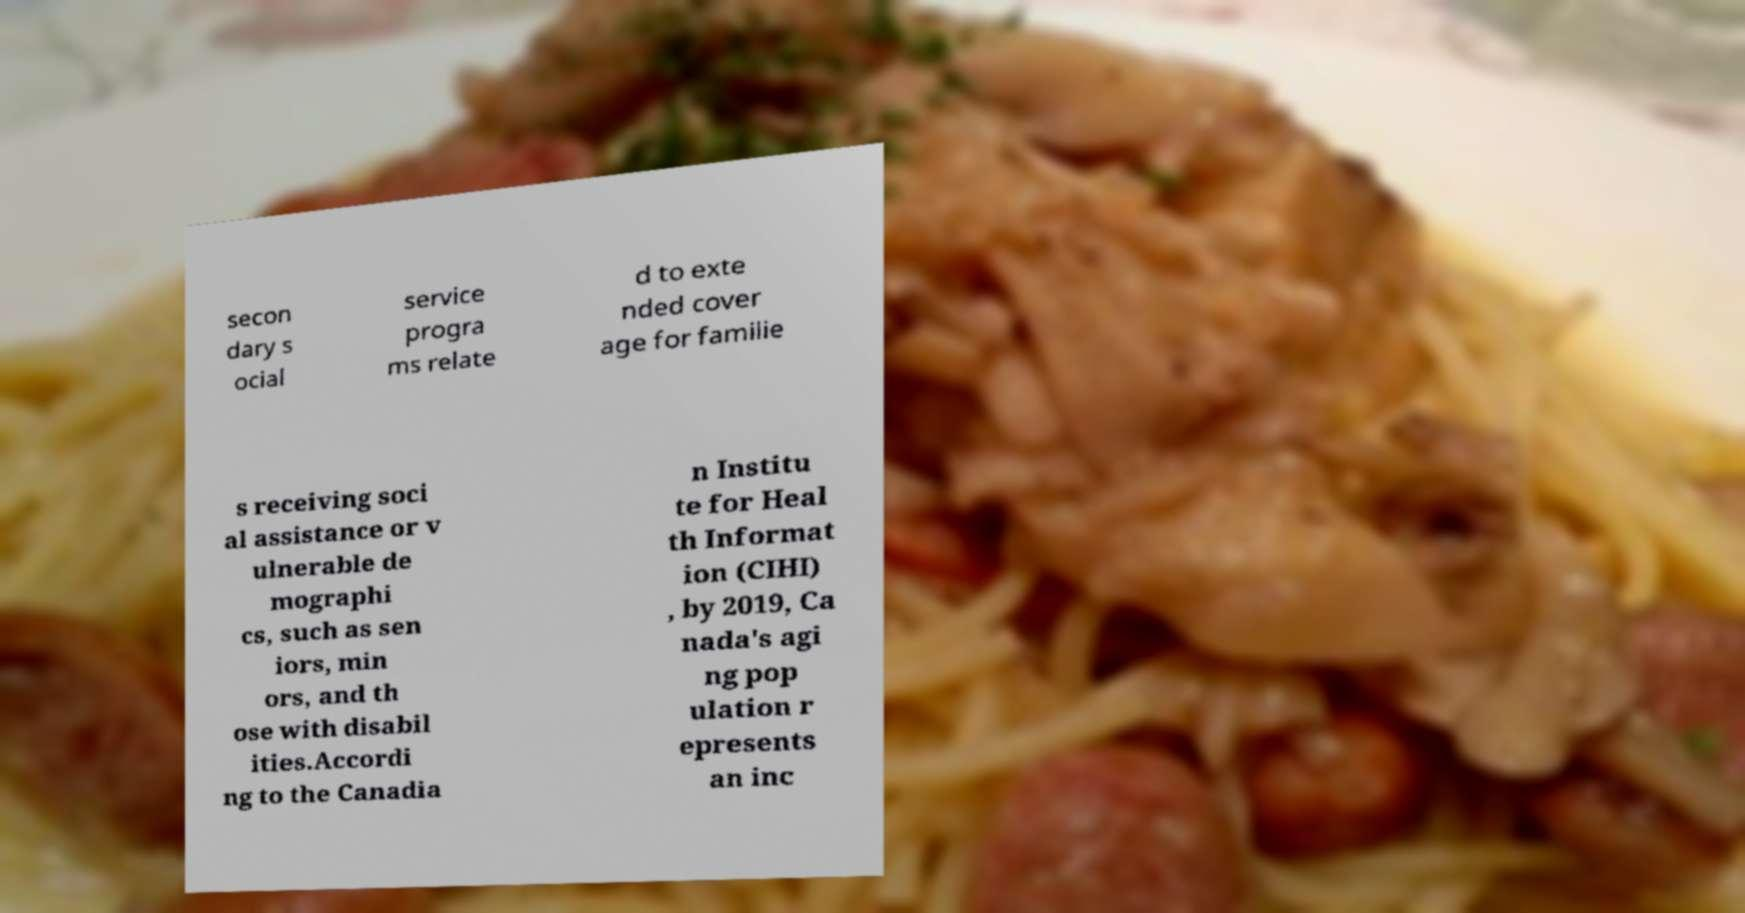I need the written content from this picture converted into text. Can you do that? secon dary s ocial service progra ms relate d to exte nded cover age for familie s receiving soci al assistance or v ulnerable de mographi cs, such as sen iors, min ors, and th ose with disabil ities.Accordi ng to the Canadia n Institu te for Heal th Informat ion (CIHI) , by 2019, Ca nada's agi ng pop ulation r epresents an inc 